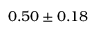Convert formula to latex. <formula><loc_0><loc_0><loc_500><loc_500>0 . 5 0 \pm 0 . 1 8</formula> 